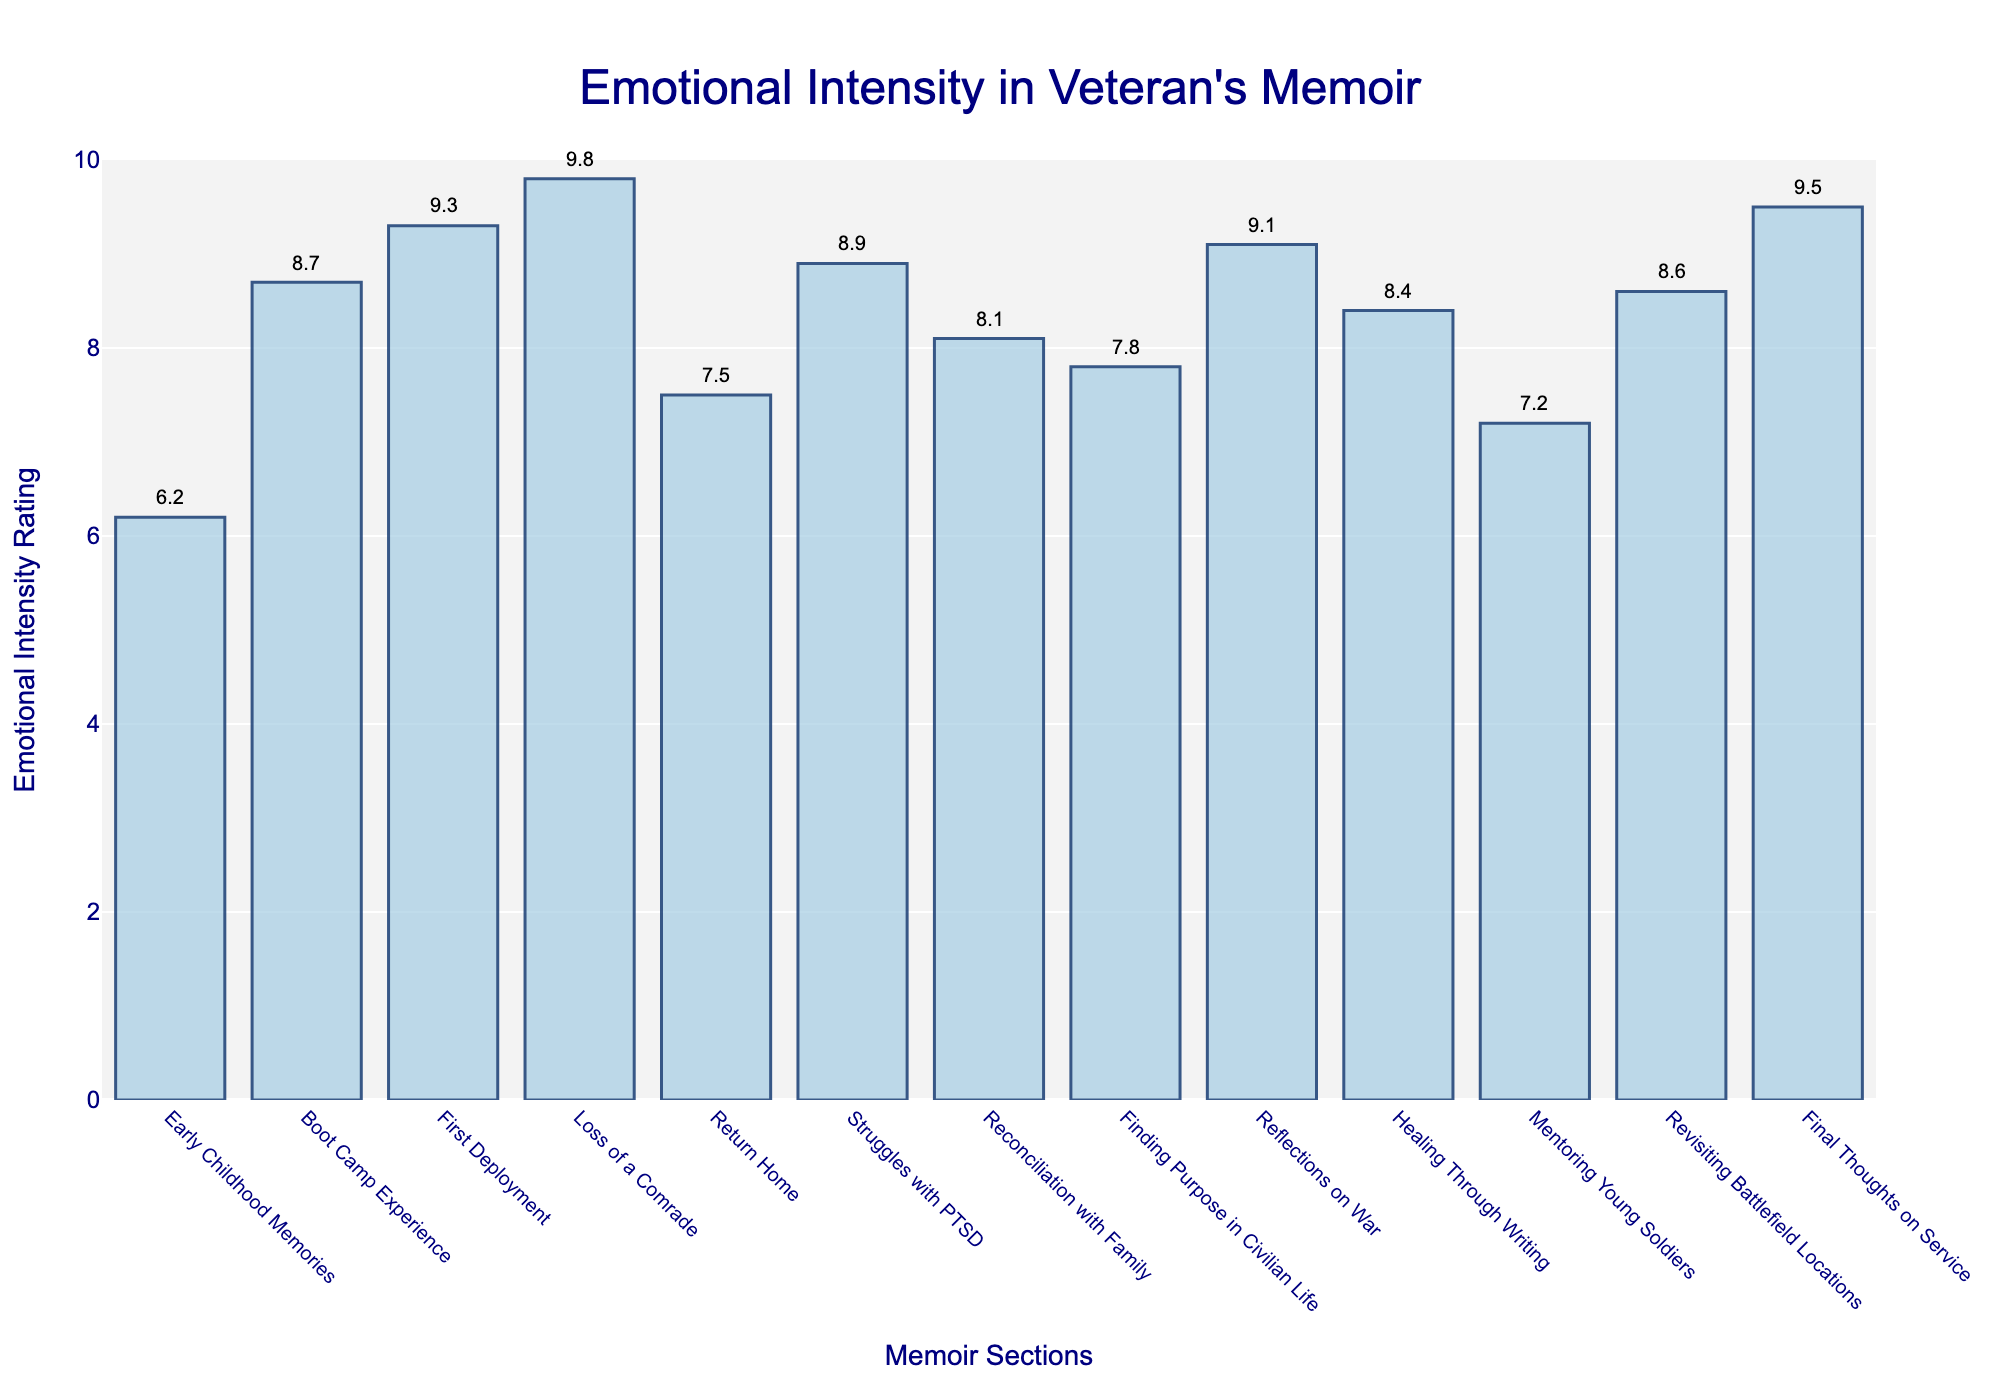Which section has the highest Emotional Intensity Rating? The highest bar in the chart corresponds to the section with the highest rating. The "Loss of a Comrade" section has the tallest bar with a rating of 9.8.
Answer: Loss of a Comrade What is the difference in Emotional Intensity Rating between "First Deployment" and "Return Home"? From the chart, the rating for "First Deployment" is 9.3, and for "Return Home" it is 7.5. The difference is 9.3 - 7.5 = 1.8.
Answer: 1.8 Are there more sections rated above 8.0 or below 8.0? By visually counting, sections above 8.0 include "Boot Camp Experience," "First Deployment," "Loss of a Comrade," "Struggles with PTSD," "Reconciliation with Family," "Reflections on War," "Healing Through Writing," and "Revisiting Battlefield Locations" (8 sections). Sections below 8.0 include "Early Childhood Memories," "Return Home," "Finding Purpose in Civilian Life," and "Mentoring Young Soldiers" (4 sections). There are more sections rated above 8.0.
Answer: Above 8.0 Which section has the lowest Emotional Intensity Rating? The shortest bar in the chart corresponds to the lowest rating. The "Early Childhood Memories" section has the shortest bar with a rating of 6.2.
Answer: Early Childhood Memories What is the average Emotional Intensity Rating of the sections "Reconciliation with Family," "Healing Through Writing," and "Mentoring Young Soldiers"? The ratings for the sections are 8.1, 8.4, and 7.2, respectively. Sum these ratings to get 8.1 + 8.4 + 7.2 = 23.7. Then divide by 3 for the average: 23.7 / 3 = 7.9.
Answer: 7.9 How much higher is the "Final Thoughts on Service" rating compared to "Finding Purpose in Civilian Life"? The rating for "Final Thoughts on Service" is 9.5, and for "Finding Purpose in Civilian Life" it is 7.8. The difference is 9.5 - 7.8 = 1.7.
Answer: 1.7 What is the median Emotional Intensity Rating of all sections? To find the median, first list the ratings in ascending order: 6.2, 7.2, 7.5, 7.8, 8.1, 8.4, 8.6, 8.7, 8.9, 9.1, 9.3, 9.5, 9.8. With 13 ratings, the median is the 7th value, which is 8.6.
Answer: 8.6 